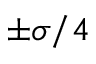<formula> <loc_0><loc_0><loc_500><loc_500>\pm \sigma / 4</formula> 